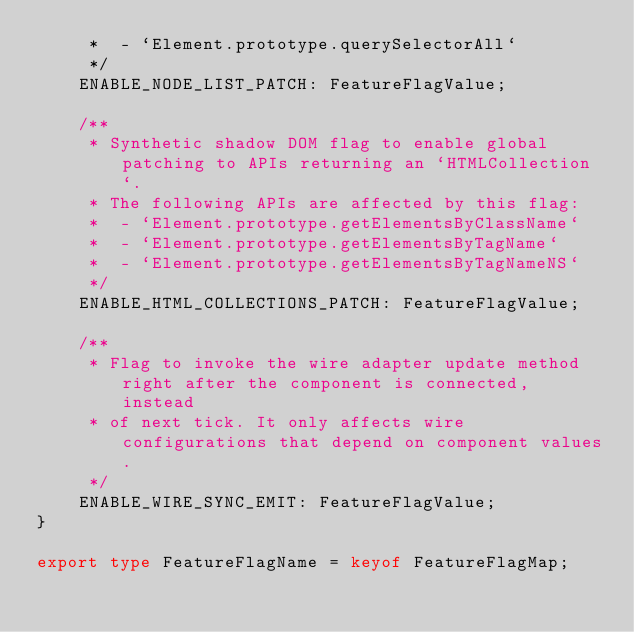Convert code to text. <code><loc_0><loc_0><loc_500><loc_500><_TypeScript_>     *  - `Element.prototype.querySelectorAll`
     */
    ENABLE_NODE_LIST_PATCH: FeatureFlagValue;

    /**
     * Synthetic shadow DOM flag to enable global patching to APIs returning an `HTMLCollection`.
     * The following APIs are affected by this flag:
     *  - `Element.prototype.getElementsByClassName`
     *  - `Element.prototype.getElementsByTagName`
     *  - `Element.prototype.getElementsByTagNameNS`
     */
    ENABLE_HTML_COLLECTIONS_PATCH: FeatureFlagValue;

    /**
     * Flag to invoke the wire adapter update method right after the component is connected, instead
     * of next tick. It only affects wire configurations that depend on component values.
     */
    ENABLE_WIRE_SYNC_EMIT: FeatureFlagValue;
}

export type FeatureFlagName = keyof FeatureFlagMap;
</code> 